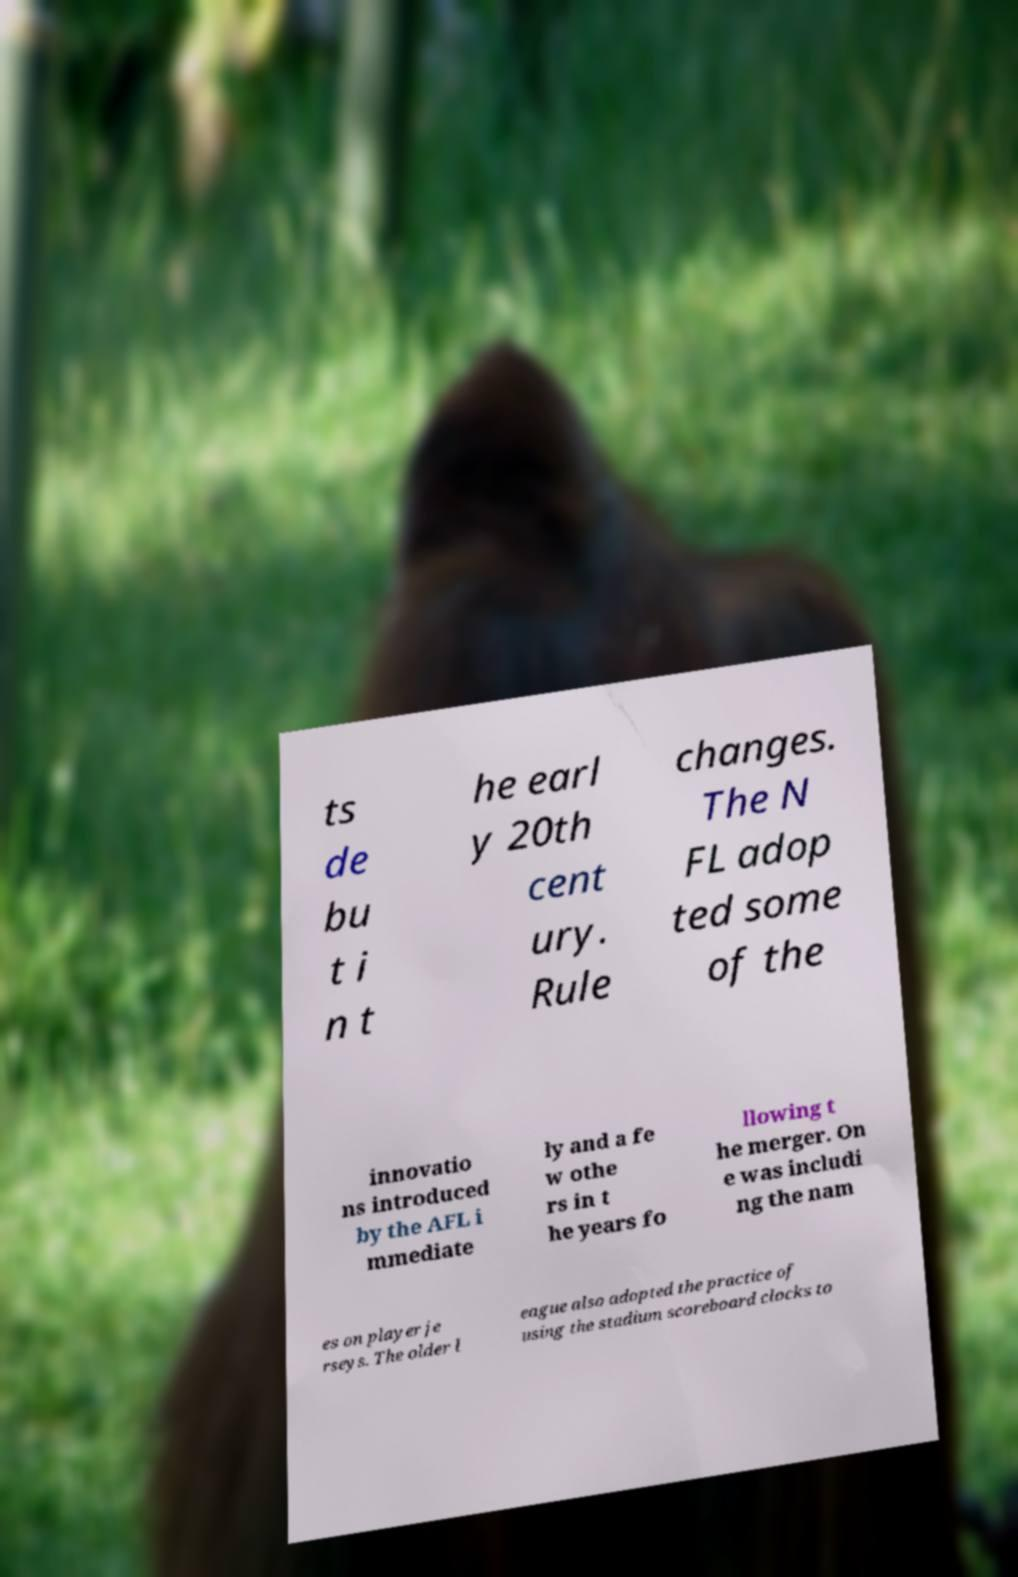Can you read and provide the text displayed in the image?This photo seems to have some interesting text. Can you extract and type it out for me? ts de bu t i n t he earl y 20th cent ury. Rule changes. The N FL adop ted some of the innovatio ns introduced by the AFL i mmediate ly and a fe w othe rs in t he years fo llowing t he merger. On e was includi ng the nam es on player je rseys. The older l eague also adopted the practice of using the stadium scoreboard clocks to 